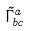<formula> <loc_0><loc_0><loc_500><loc_500>\tilde { \Gamma } _ { b c } ^ { a }</formula> 